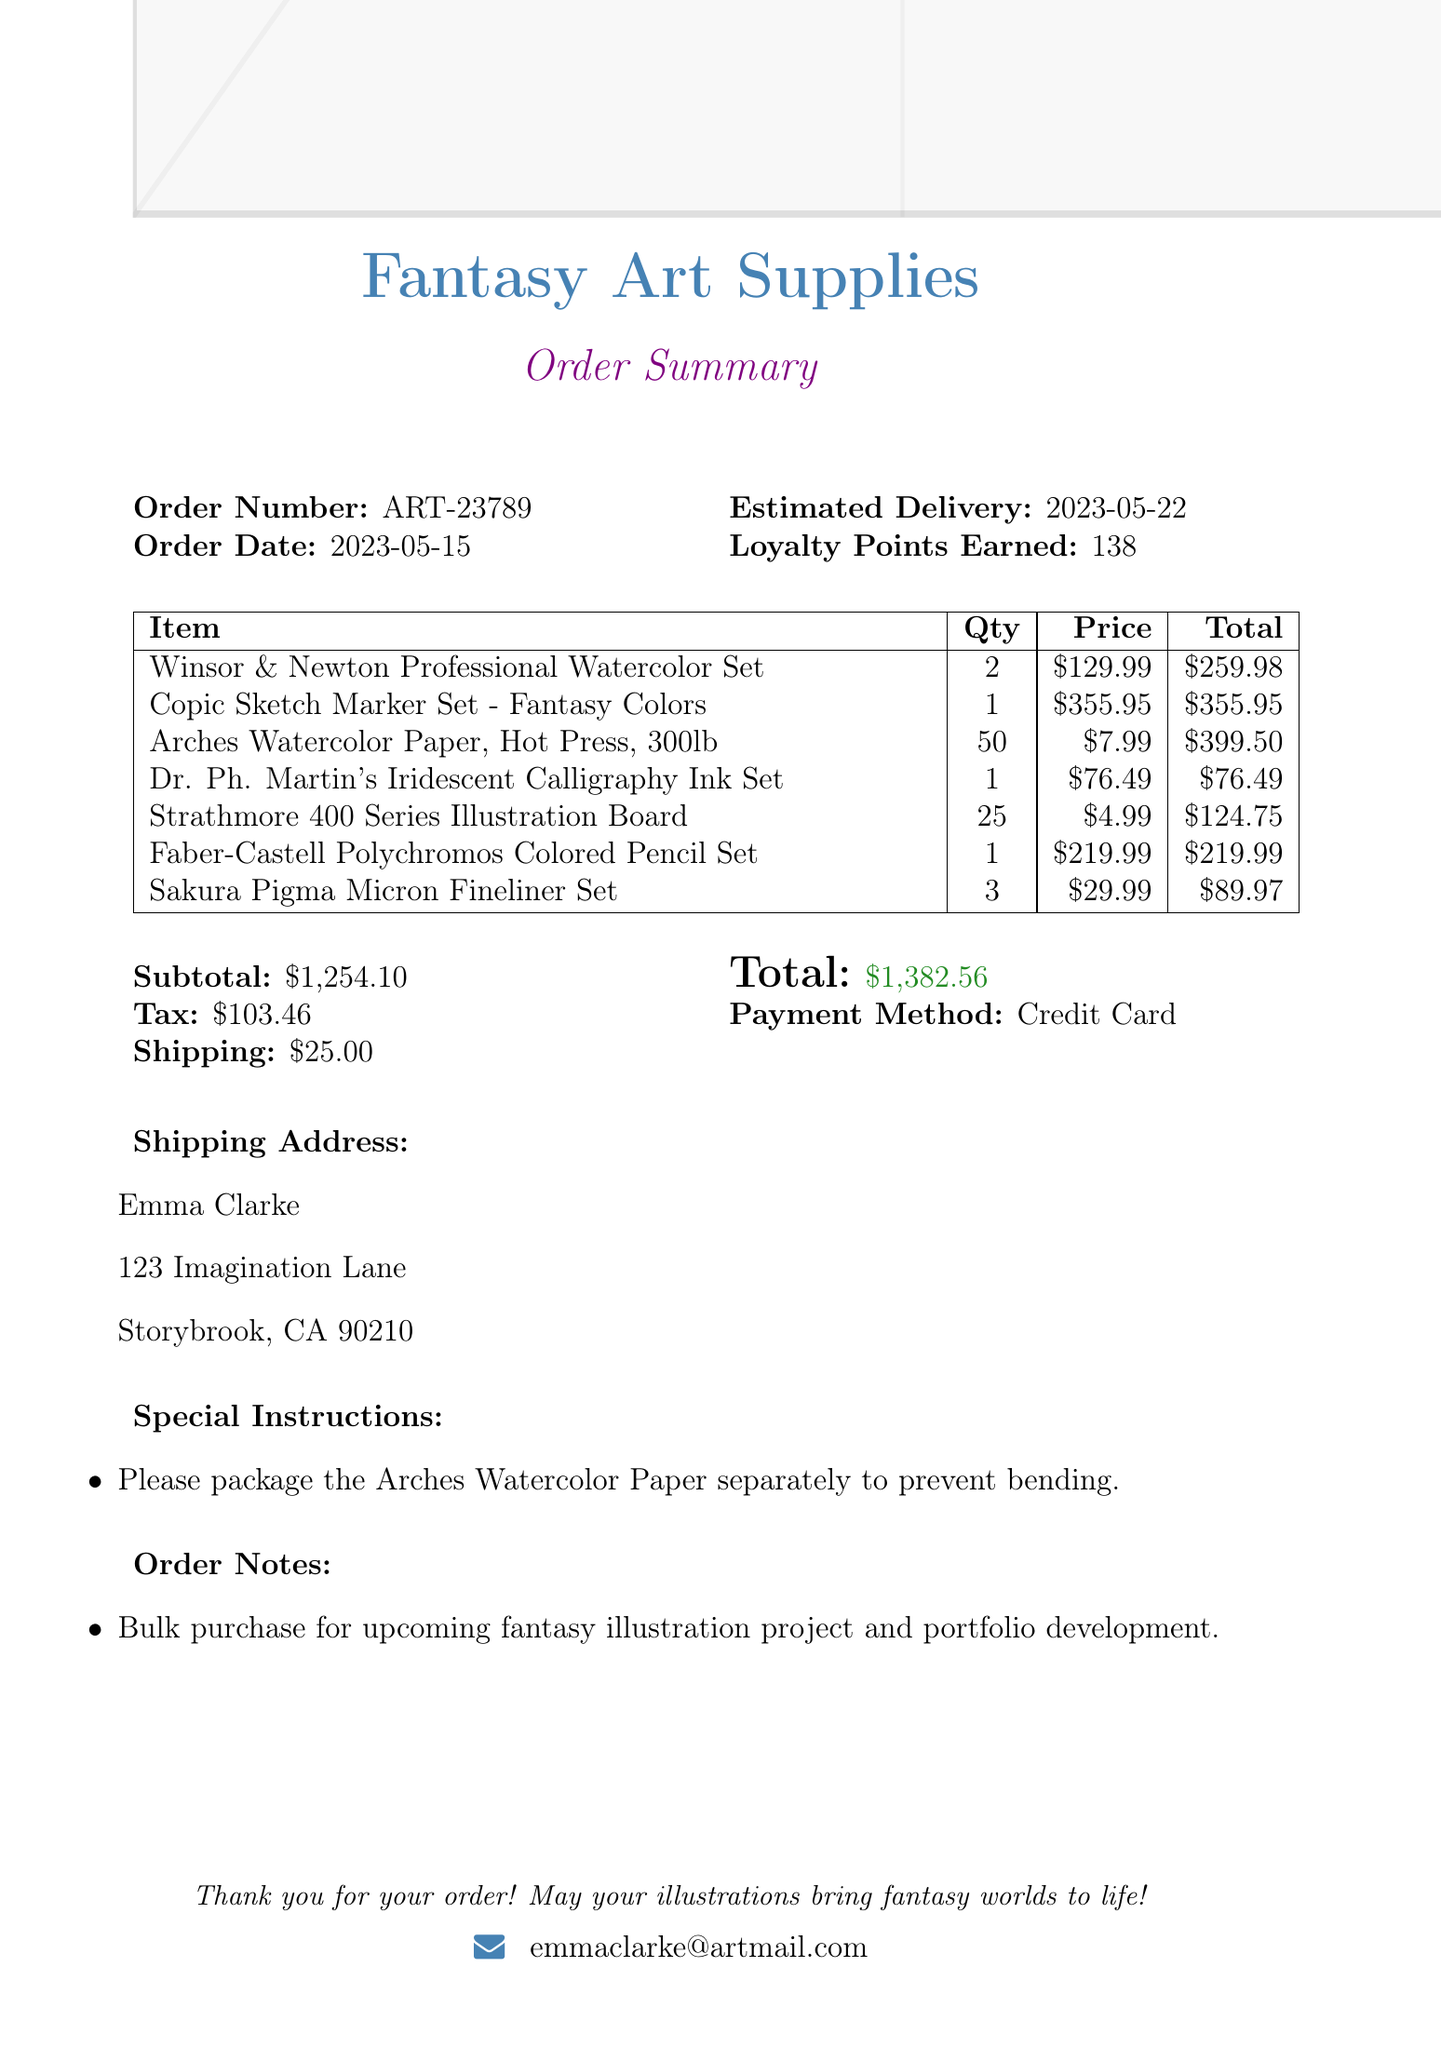What is the order number? The order number is listed at the top of the document under Order Number.
Answer: ART-23789 What is the total amount of the order? The total amount is calculated by summing the subtotal, tax, and shipping in the document.
Answer: $1,382.56 Who is the customer? The customer's name is provided in the document, which appears right after the order summary title.
Answer: Emma Clarke How many items were ordered in total? The document lists the number of each item ordered and we need to count them.
Answer: 7 What special instruction was given for packaging? The special instructions section contains specific requests from the customer regarding the packaging.
Answer: Please package the Arches Watercolor Paper separately to prevent bending What payment method was used for the order? The payment method is explicitly stated in the document under Payment Method.
Answer: Credit Card How much tax was included in the order? The tax amount is listed in the financial summary section of the document.
Answer: $103.46 What was the estimated delivery date? The estimated delivery date is specified in the document and indicates when the order is expected to arrive.
Answer: 2023-05-22 What is the customer’s email address? The email address is provided under the customer information section in the document.
Answer: emmaclarke@artmail.com 